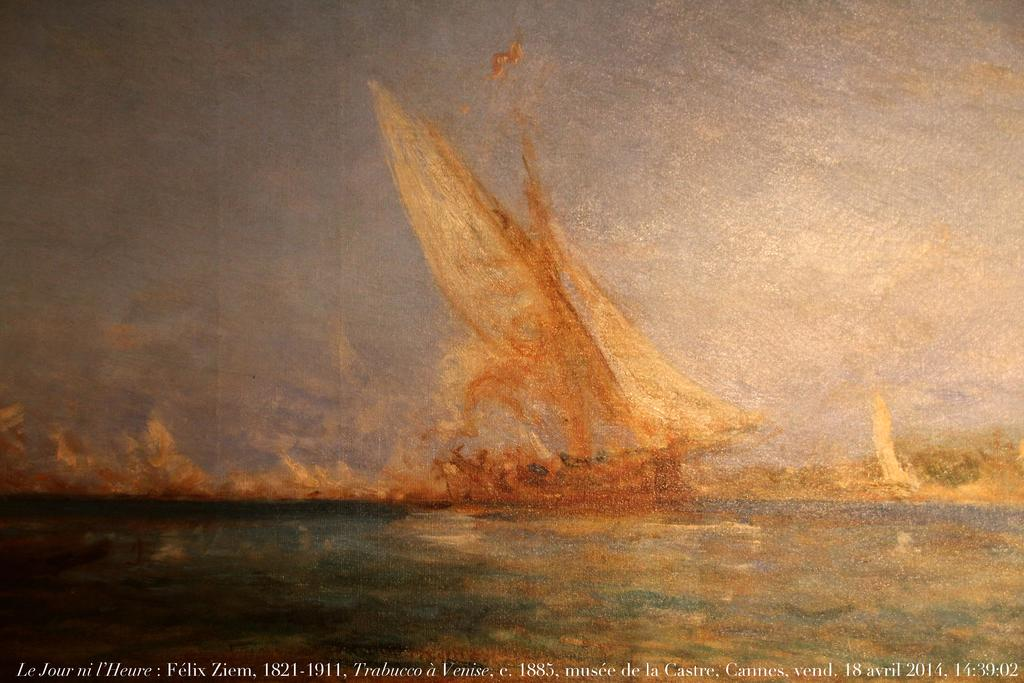<image>
Present a compact description of the photo's key features. A painting of a ship called Le Jour ni l'Heure by Felix Ziem painted between 1821 and 1911. 